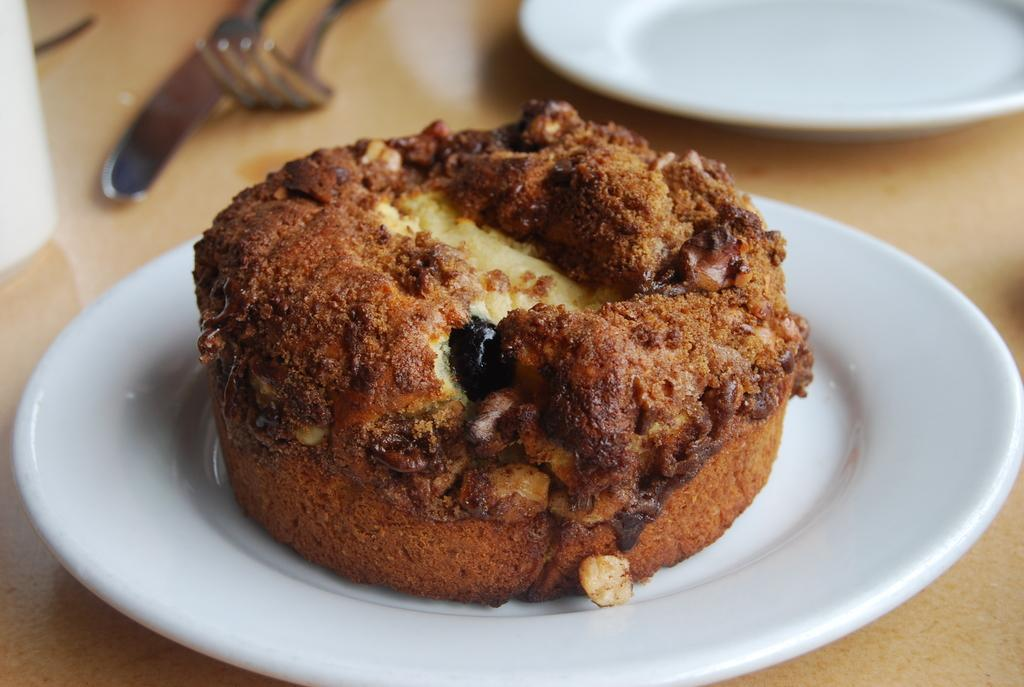What is the main food item visible in the image? There is a brownie in the image. What is the brownie placed on? The brownie is on a white plate. Where is the white plate with the brownie located? The white plate with the brownie is kept on a table. What type of fear can be seen on the trees in the image? There are no trees present in the image, and therefore no fear can be observed on them. 